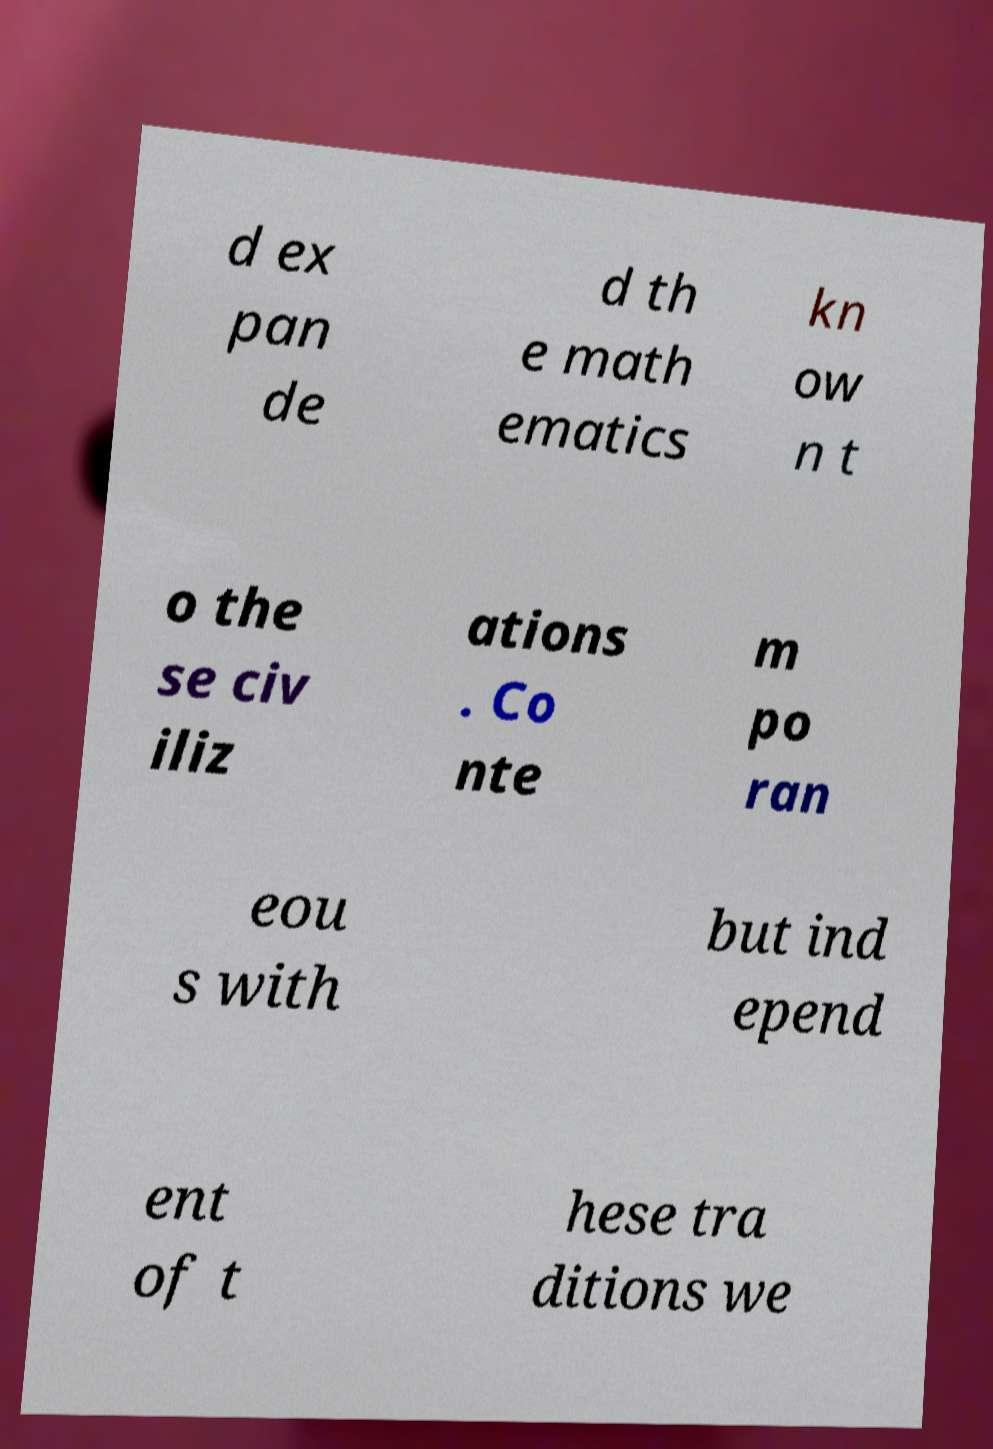There's text embedded in this image that I need extracted. Can you transcribe it verbatim? d ex pan de d th e math ematics kn ow n t o the se civ iliz ations . Co nte m po ran eou s with but ind epend ent of t hese tra ditions we 